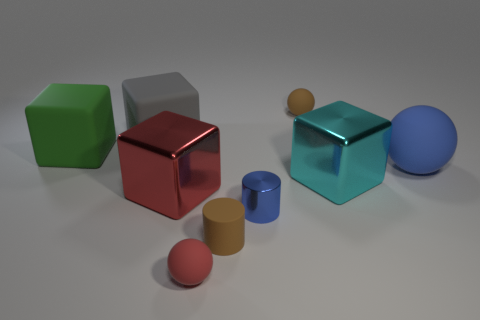Subtract 1 blocks. How many blocks are left? 3 Subtract all balls. How many objects are left? 6 Subtract 0 yellow spheres. How many objects are left? 9 Subtract all tiny purple rubber balls. Subtract all big green rubber things. How many objects are left? 8 Add 7 green rubber cubes. How many green rubber cubes are left? 8 Add 8 tiny matte cylinders. How many tiny matte cylinders exist? 9 